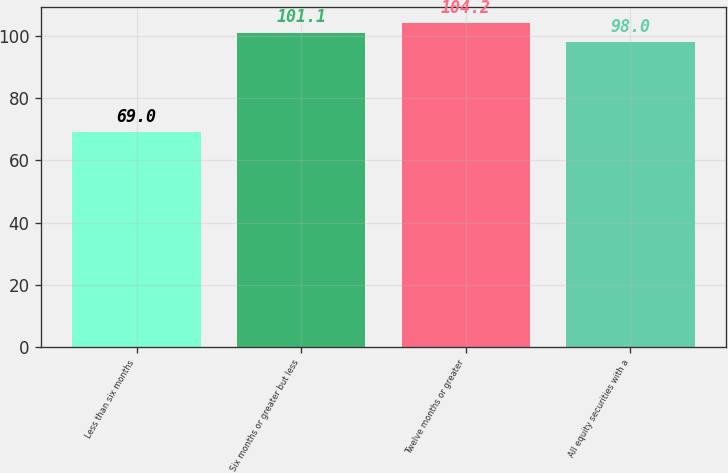Convert chart to OTSL. <chart><loc_0><loc_0><loc_500><loc_500><bar_chart><fcel>Less than six months<fcel>Six months or greater but less<fcel>Twelve months or greater<fcel>All equity securities with a<nl><fcel>69<fcel>101.1<fcel>104.2<fcel>98<nl></chart> 